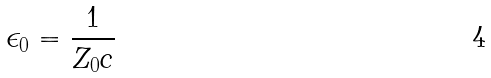<formula> <loc_0><loc_0><loc_500><loc_500>\epsilon _ { 0 } = \frac { 1 } { Z _ { 0 } c }</formula> 